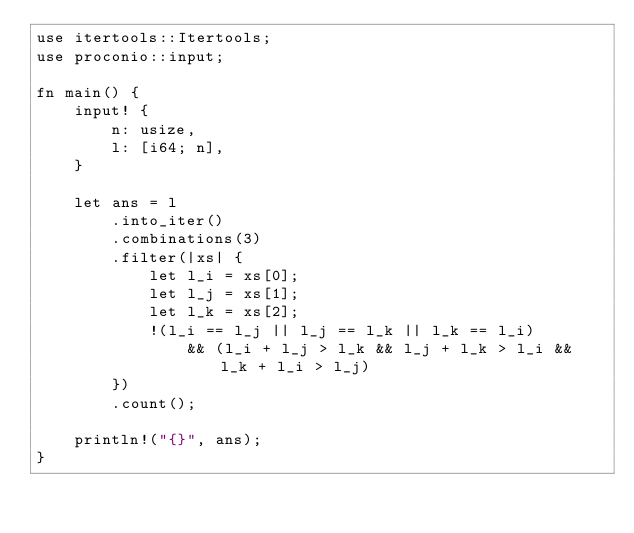Convert code to text. <code><loc_0><loc_0><loc_500><loc_500><_Rust_>use itertools::Itertools;
use proconio::input;

fn main() {
    input! {
        n: usize,
        l: [i64; n],
    }

    let ans = l
        .into_iter()
        .combinations(3)
        .filter(|xs| {
            let l_i = xs[0];
            let l_j = xs[1];
            let l_k = xs[2];
            !(l_i == l_j || l_j == l_k || l_k == l_i)
                && (l_i + l_j > l_k && l_j + l_k > l_i && l_k + l_i > l_j)
        })
        .count();

    println!("{}", ans);
}
</code> 